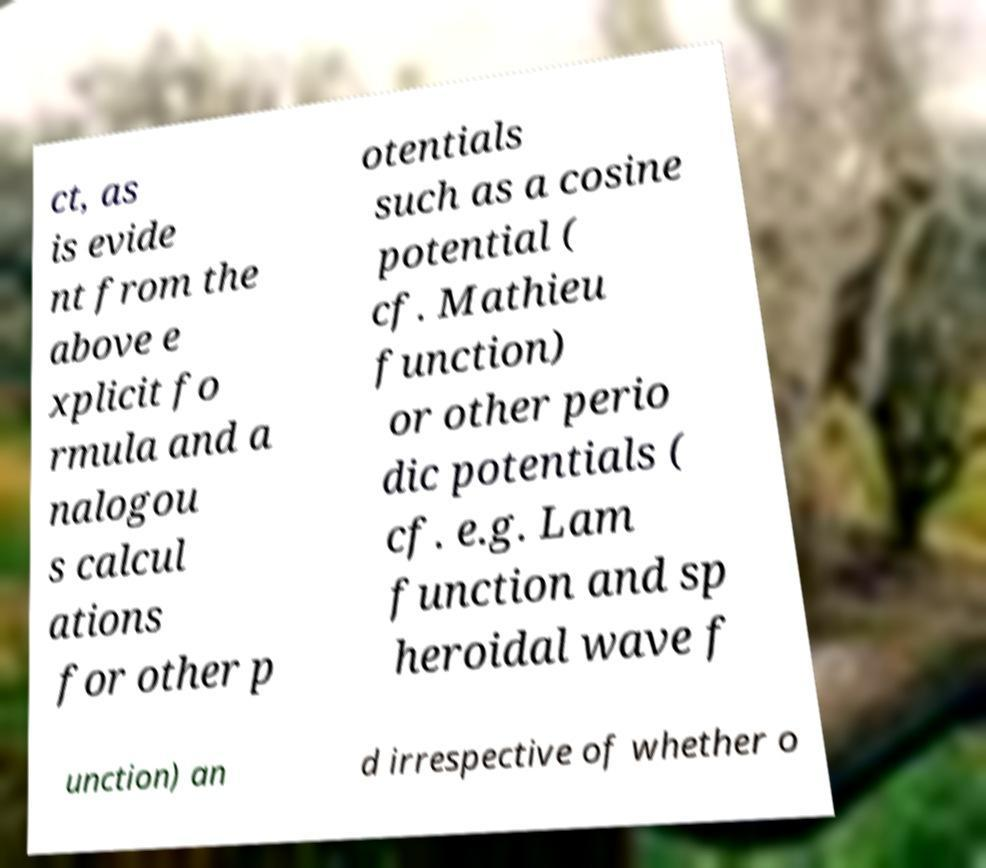Can you read and provide the text displayed in the image?This photo seems to have some interesting text. Can you extract and type it out for me? ct, as is evide nt from the above e xplicit fo rmula and a nalogou s calcul ations for other p otentials such as a cosine potential ( cf. Mathieu function) or other perio dic potentials ( cf. e.g. Lam function and sp heroidal wave f unction) an d irrespective of whether o 